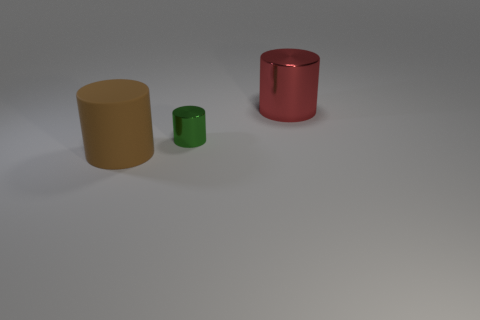Add 2 red shiny things. How many objects exist? 5 Subtract 0 blue cylinders. How many objects are left? 3 Subtract all large matte things. Subtract all brown matte things. How many objects are left? 1 Add 2 brown cylinders. How many brown cylinders are left? 3 Add 1 cyan cylinders. How many cyan cylinders exist? 1 